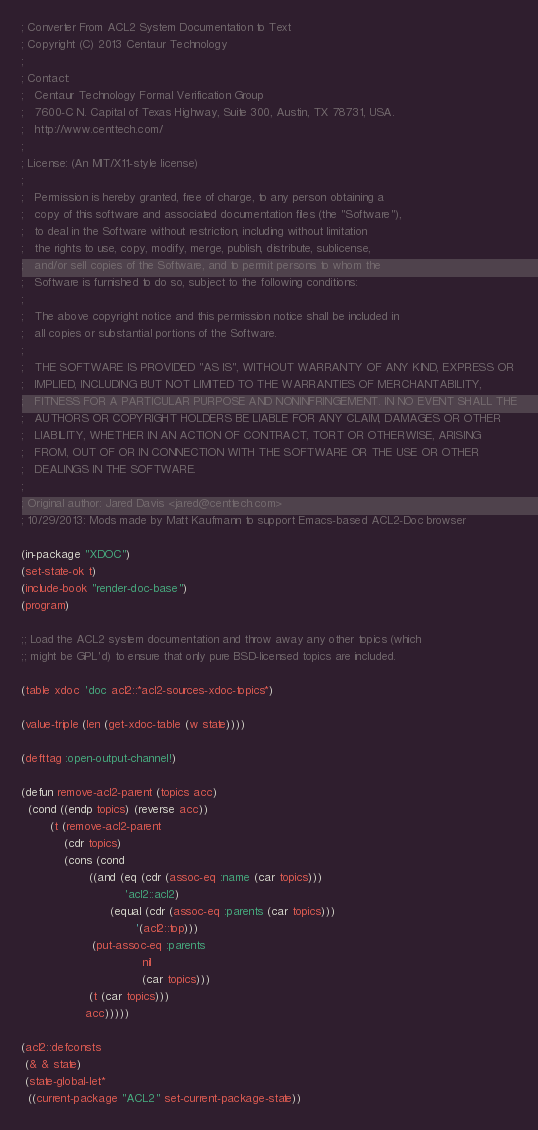Convert code to text. <code><loc_0><loc_0><loc_500><loc_500><_Lisp_>; Converter From ACL2 System Documentation to Text
; Copyright (C) 2013 Centaur Technology
;
; Contact:
;   Centaur Technology Formal Verification Group
;   7600-C N. Capital of Texas Highway, Suite 300, Austin, TX 78731, USA.
;   http://www.centtech.com/
;
; License: (An MIT/X11-style license)
;
;   Permission is hereby granted, free of charge, to any person obtaining a
;   copy of this software and associated documentation files (the "Software"),
;   to deal in the Software without restriction, including without limitation
;   the rights to use, copy, modify, merge, publish, distribute, sublicense,
;   and/or sell copies of the Software, and to permit persons to whom the
;   Software is furnished to do so, subject to the following conditions:
;
;   The above copyright notice and this permission notice shall be included in
;   all copies or substantial portions of the Software.
;
;   THE SOFTWARE IS PROVIDED "AS IS", WITHOUT WARRANTY OF ANY KIND, EXPRESS OR
;   IMPLIED, INCLUDING BUT NOT LIMITED TO THE WARRANTIES OF MERCHANTABILITY,
;   FITNESS FOR A PARTICULAR PURPOSE AND NONINFRINGEMENT. IN NO EVENT SHALL THE
;   AUTHORS OR COPYRIGHT HOLDERS BE LIABLE FOR ANY CLAIM, DAMAGES OR OTHER
;   LIABILITY, WHETHER IN AN ACTION OF CONTRACT, TORT OR OTHERWISE, ARISING
;   FROM, OUT OF OR IN CONNECTION WITH THE SOFTWARE OR THE USE OR OTHER
;   DEALINGS IN THE SOFTWARE.
;
; Original author: Jared Davis <jared@centtech.com>
; 10/29/2013: Mods made by Matt Kaufmann to support Emacs-based ACL2-Doc browser

(in-package "XDOC")
(set-state-ok t)
(include-book "render-doc-base")
(program)

;; Load the ACL2 system documentation and throw away any other topics (which
;; might be GPL'd) to ensure that only pure BSD-licensed topics are included.

(table xdoc 'doc acl2::*acl2-sources-xdoc-topics*)

(value-triple (len (get-xdoc-table (w state))))

(defttag :open-output-channel!)

(defun remove-acl2-parent (topics acc)
  (cond ((endp topics) (reverse acc))
        (t (remove-acl2-parent
            (cdr topics)
            (cons (cond
                   ((and (eq (cdr (assoc-eq :name (car topics)))
                             'acl2::acl2)
                         (equal (cdr (assoc-eq :parents (car topics)))
                                '(acl2::top)))
                    (put-assoc-eq :parents
                                  nil
                                  (car topics)))
                   (t (car topics)))
                  acc)))))

(acl2::defconsts
 (& & state)
 (state-global-let*
  ((current-package "ACL2" set-current-package-state))</code> 